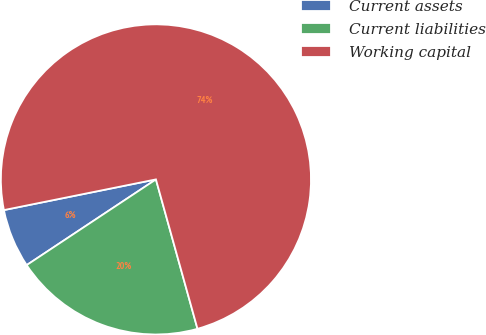Convert chart to OTSL. <chart><loc_0><loc_0><loc_500><loc_500><pie_chart><fcel>Current assets<fcel>Current liabilities<fcel>Working capital<nl><fcel>6.15%<fcel>20.0%<fcel>73.85%<nl></chart> 